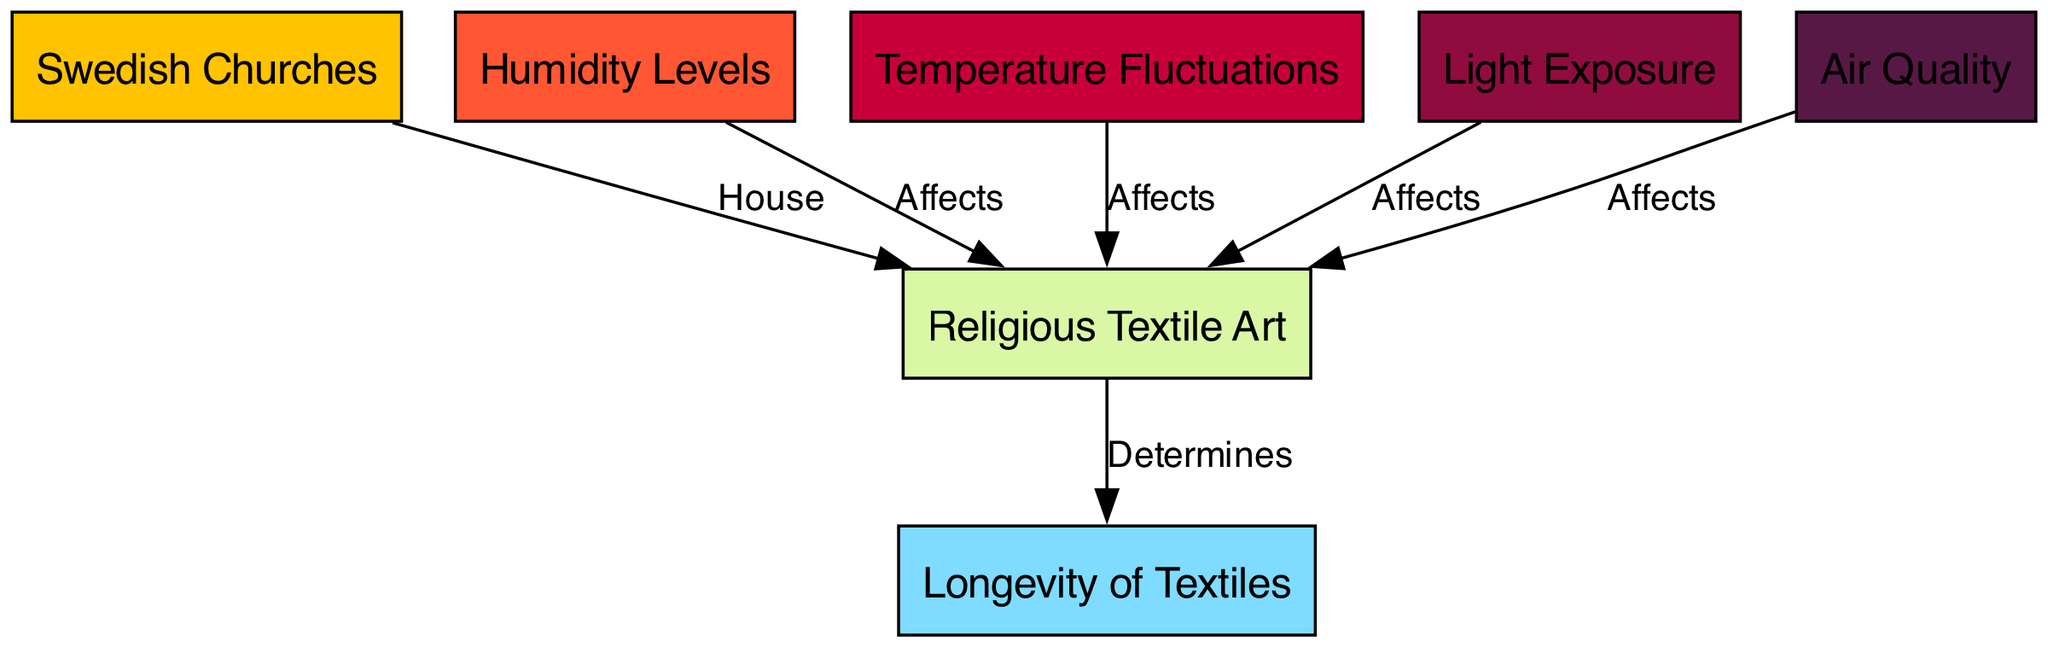What is the total number of nodes in the diagram? The diagram contains a total of 7 nodes: Swedish Churches, Religious Textile Art, Humidity Levels, Temperature Fluctuations, Light Exposure, Air Quality, and Longevity of Textiles.
Answer: 7 Which node affects the longevity of textiles? The edge goes from Religious Textile Art to Longevity of Textiles, indicating a determining relationship. Thus, the node that affects the longevity of textiles is Religious Textile Art.
Answer: Religious Textile Art What environmental factor directly affects the textiles related to air? The edge labeled "Affects" goes from Air Quality to Religious Textile Art, indicating that air quality is an environmental factor that directly affects the textiles.
Answer: Air Quality How many environmental factors affect the religious textile art? There are four environmental factors affecting the religious textile art: Humidity Levels, Temperature Fluctuations, Light Exposure, and Air Quality, as indicated by the edges from these nodes to the Religious Textile Art node.
Answer: 4 What relationship exists between humidity and textiles? The diagram shows an edge labeled "Affects" from Humidity Levels to Religious Textile Art, illustrating that humidity affects the textiles.
Answer: Affects Which factors are specifically listed as affecting religious textile art? The diagram highlights four specific factors: Humidity Levels, Temperature Fluctuations, Light Exposure, and Air Quality, as indicated by the direct connections to the textiles node.
Answer: Humidity Levels, Temperature Fluctuations, Light Exposure, Air Quality What determines the preservation of textiles? The edge in the diagram from Religious Textile Art to Longevity of Textiles labeled "Determines" indicates that the preservation of textiles is determined by the textiles themselves.
Answer: Textiles Which node serves as a house for the religious textile art? The direct connection from Swedish Churches to Religious Textile Art indicates that Swedish Churches house the religious textile art.
Answer: Swedish Churches 